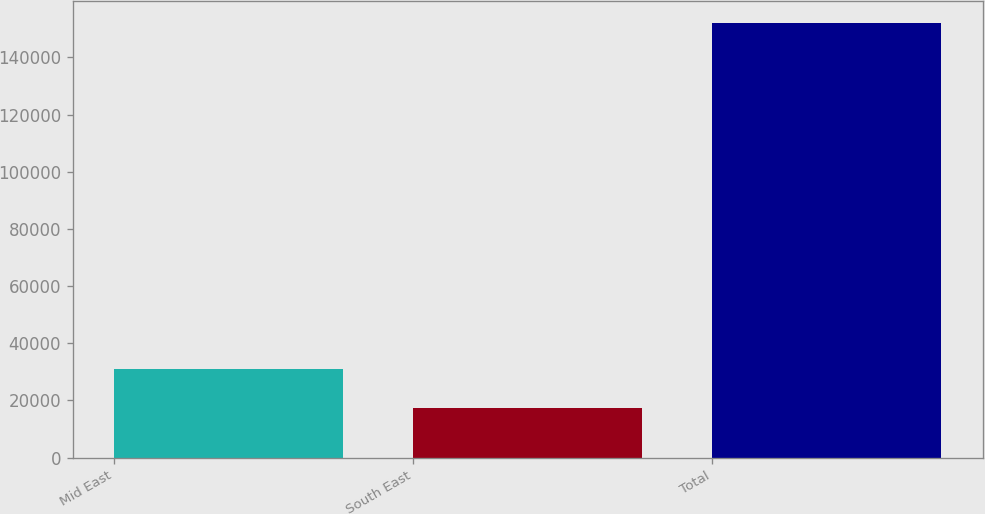Convert chart to OTSL. <chart><loc_0><loc_0><loc_500><loc_500><bar_chart><fcel>Mid East<fcel>South East<fcel>Total<nl><fcel>30879.4<fcel>17406<fcel>152140<nl></chart> 